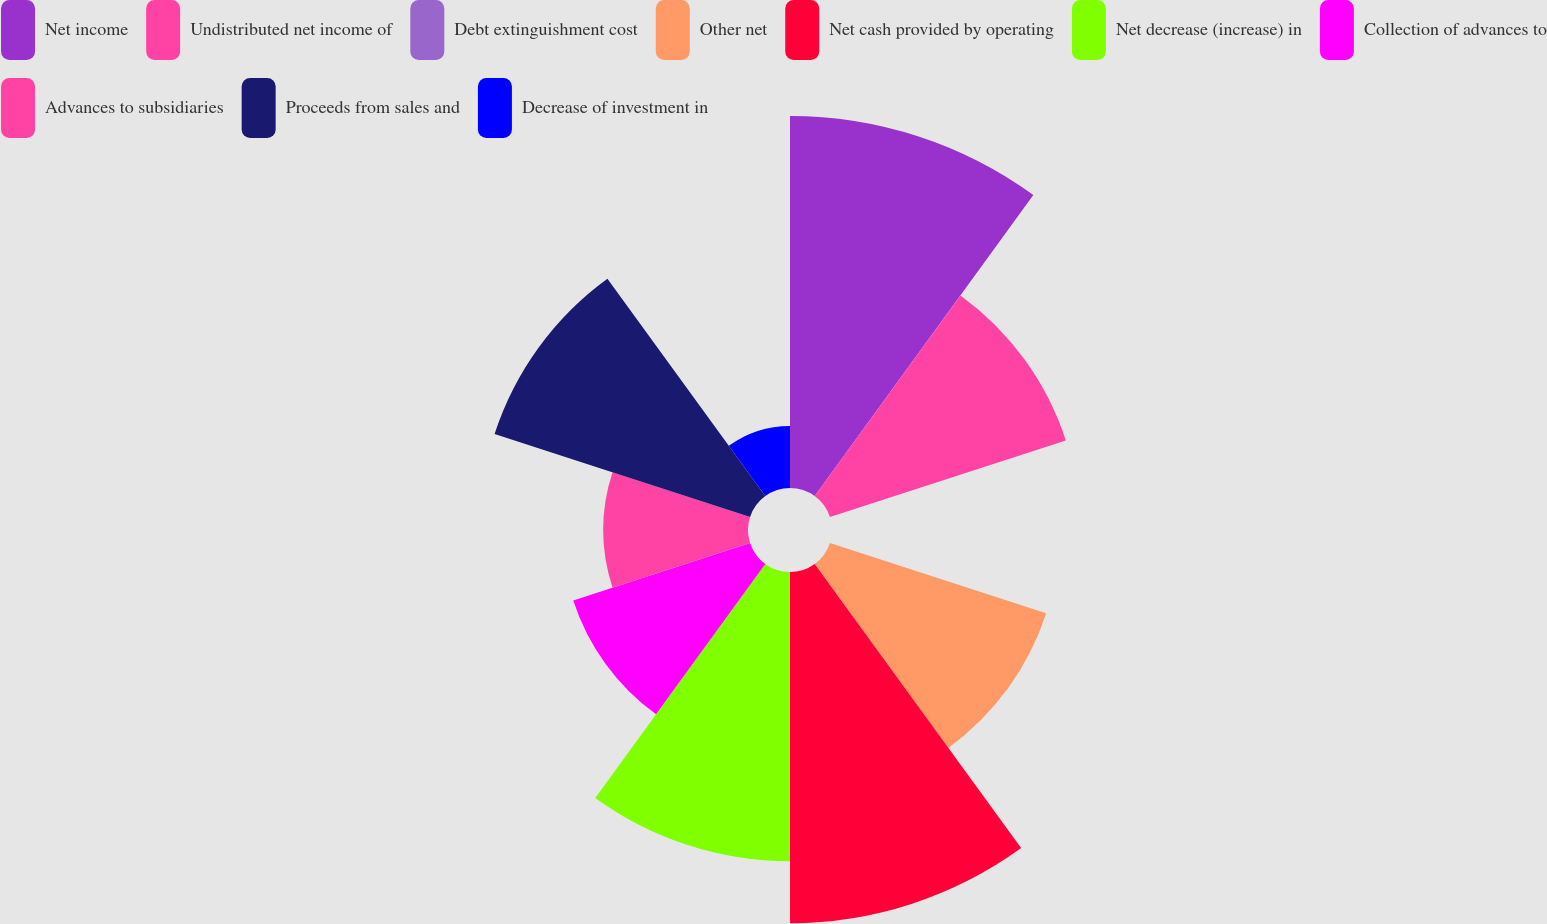<chart> <loc_0><loc_0><loc_500><loc_500><pie_chart><fcel>Net income<fcel>Undistributed net income of<fcel>Debt extinguishment cost<fcel>Other net<fcel>Net cash provided by operating<fcel>Net decrease (increase) in<fcel>Collection of advances to<fcel>Advances to subsidiaries<fcel>Proceeds from sales and<fcel>Decrease of investment in<nl><fcel>17.31%<fcel>11.54%<fcel>0.0%<fcel>10.58%<fcel>16.34%<fcel>13.46%<fcel>8.65%<fcel>6.73%<fcel>12.5%<fcel>2.89%<nl></chart> 